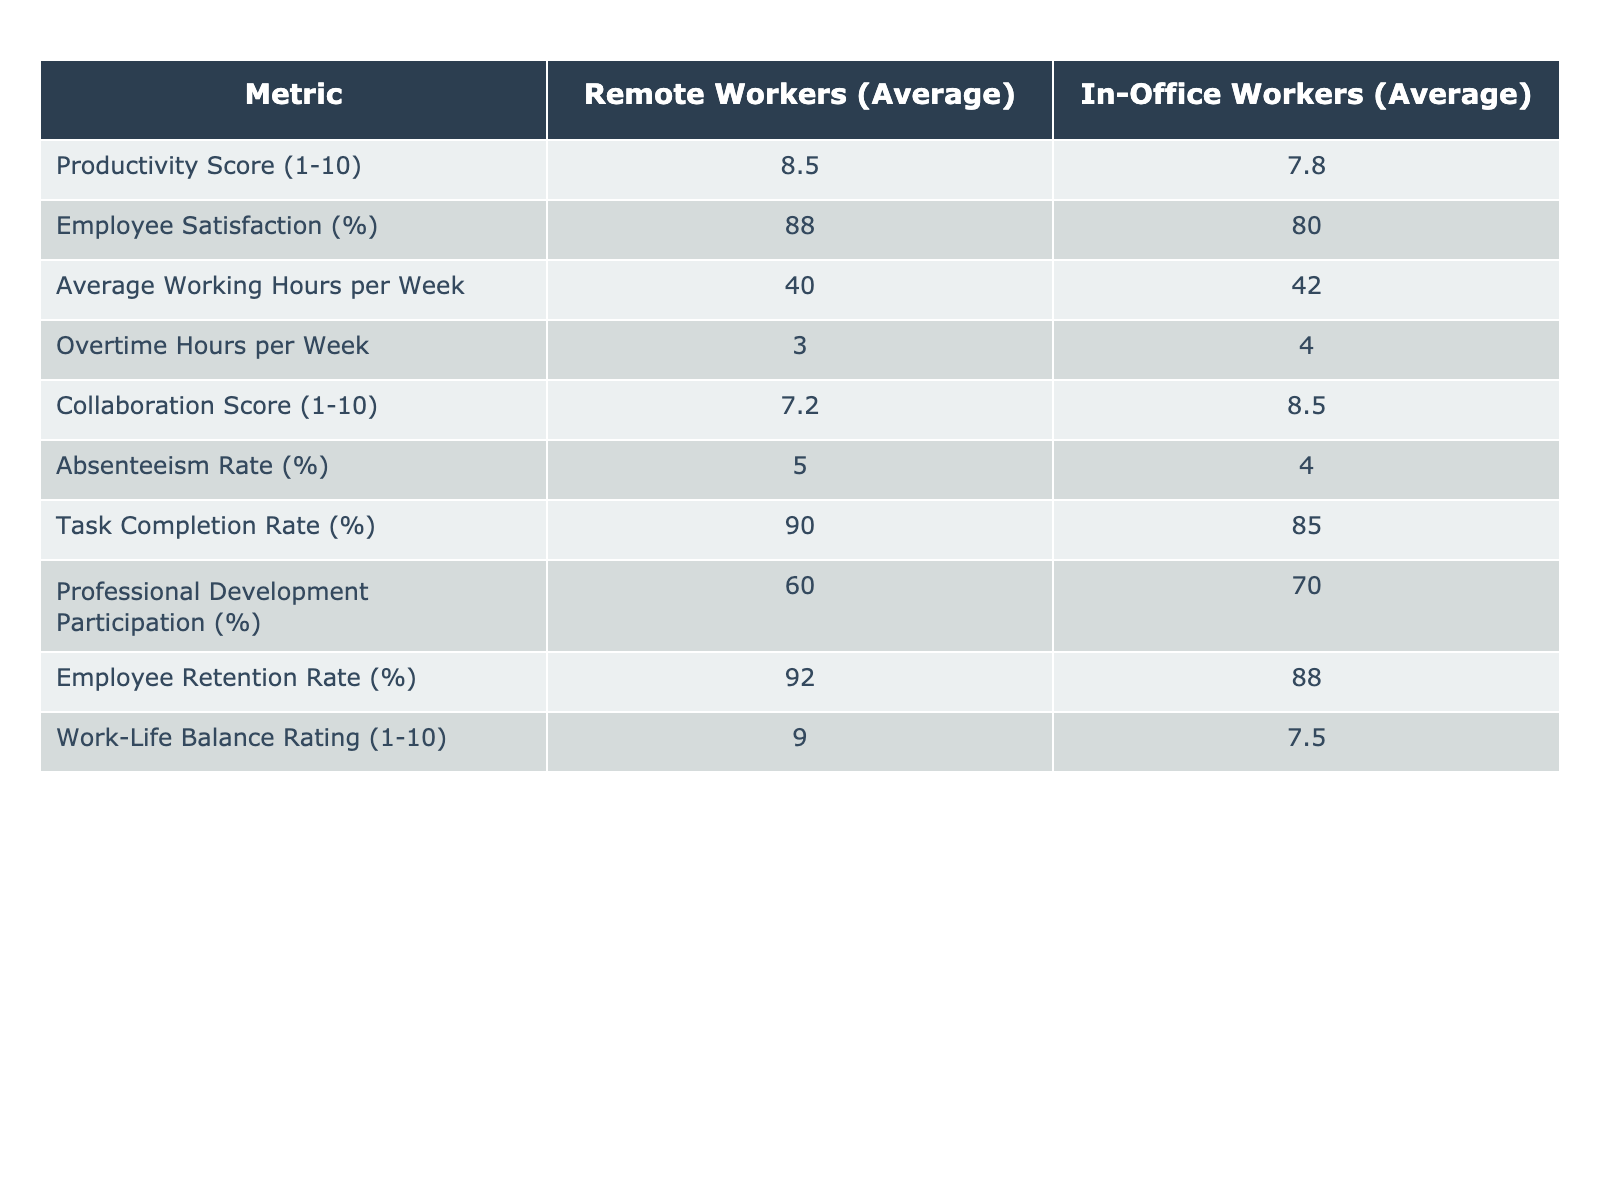What is the average productivity score for remote workers? The table shows the average productivity score for remote workers as 8.5 out of 10.
Answer: 8.5 What is the employee satisfaction percentage for in-office workers? According to the table, the employee satisfaction percentage for in-office workers is 80%.
Answer: 80% How many average working hours per week do remote workers have compared to in-office workers? Remote workers have an average of 40 working hours per week, while in-office workers have 42 hours.
Answer: Remote: 40, In-Office: 42 What is the difference in collaboration scores between remote and in-office workers? The collaboration score for remote workers is 7.2, while for in-office workers, it is 8.5. The difference is 8.5 - 7.2 = 1.3.
Answer: 1.3 Is the absenteeism rate higher for remote workers compared to in-office workers? The absenteeism rate for remote workers is 5%, and for in-office workers, it is 4%. Since 5% > 4%, the statement is true.
Answer: Yes What is the average task completion rate difference between remote and in-office workers? The task completion rate for remote workers is 90%, while it is 85% for in-office workers. The difference is 90% - 85% = 5%.
Answer: 5% What is the average work-life balance rating for both types of workers? Remote workers have a rating of 9.0, and in-office workers have a rating of 7.5. To find the average, (9.0 + 7.5) / 2 = 8.25.
Answer: 8.25 What is the percentage difference in professional development participation between remote and in-office workers? Remote workers have 60% participation and in-office workers have 70%. The difference is 70% - 60% = 10%. To find the percentage difference with respect to in-office workers, (10% / 70%) * 100 = approximately 14.29%.
Answer: 14.29% Which type of worker has a higher employee retention rate? The employee retention rate for remote workers is 92%, while for in-office workers, it is 88%. Since 92% > 88%, remote workers have a higher retention rate.
Answer: Remote workers Which group has a better work-life balance rating, and by how much? Remote workers have a rating of 9.0 and in-office workers have a rating of 7.5. The difference is 9.0 - 7.5 = 1.5. Thus, remote workers have a better work-life balance by 1.5.
Answer: Remote workers by 1.5 